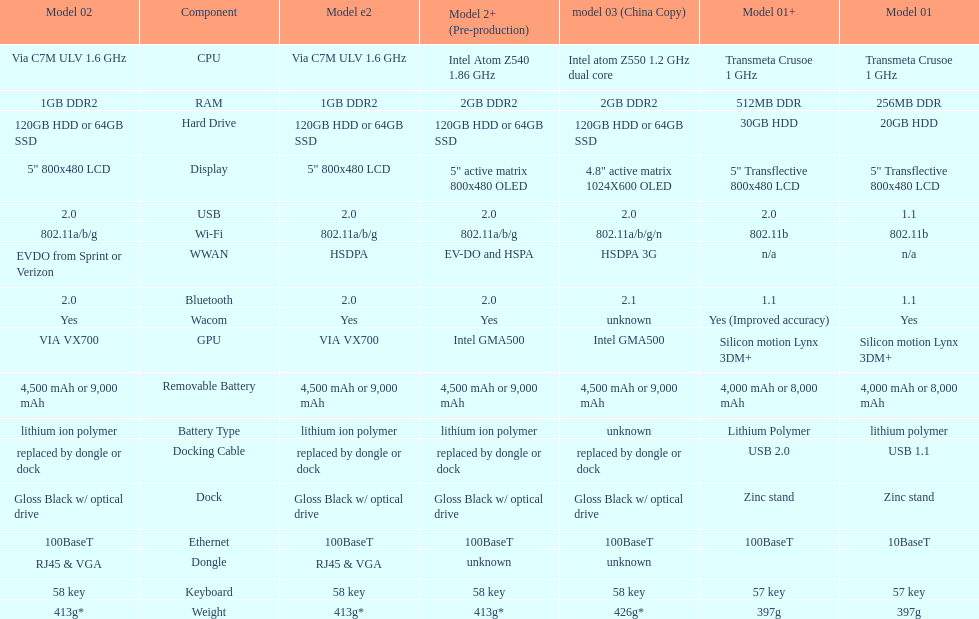What is the total number of components on the chart? 18. 